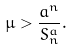Convert formula to latex. <formula><loc_0><loc_0><loc_500><loc_500>\mu > \frac { a ^ { n } } { S _ { n } ^ { a } } .</formula> 